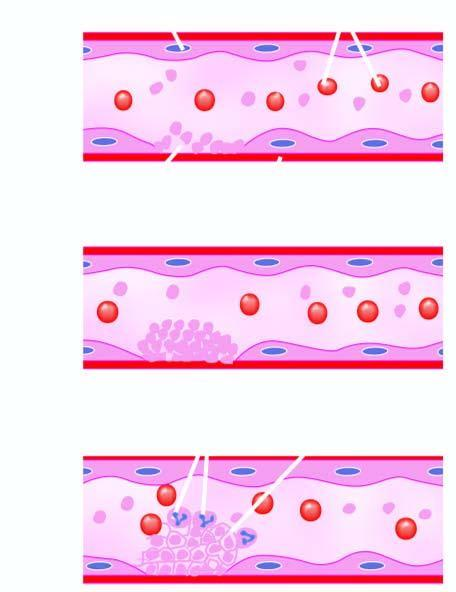does the myocardial muscle fibres form fibrin strands in which are entangled some leucocytes and red cells and a tight meshwork is formed called thrombus?
Answer the question using a single word or phrase. No 